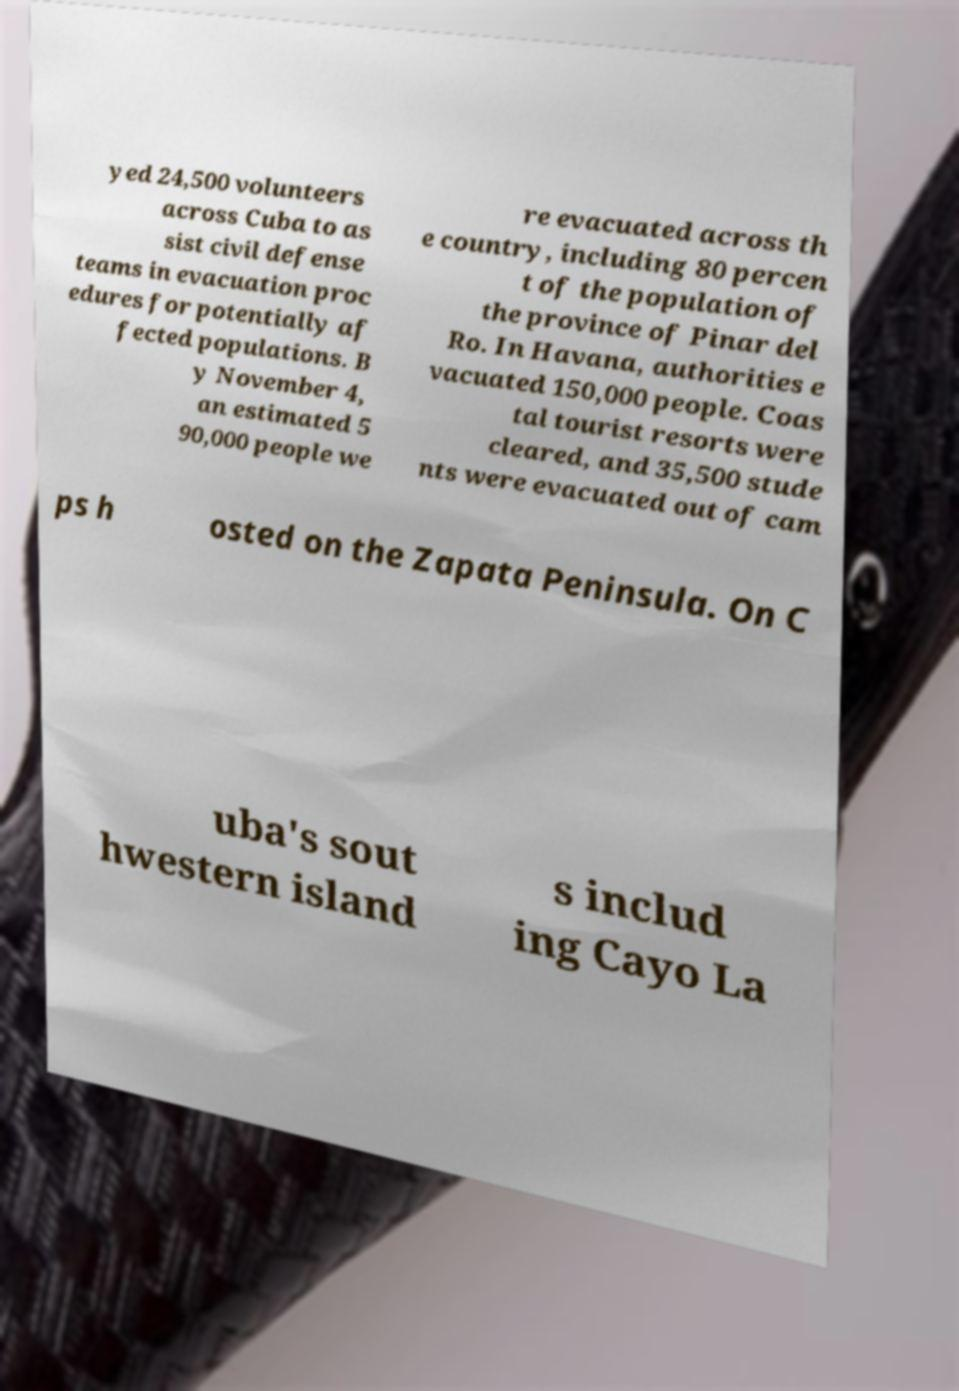Can you read and provide the text displayed in the image?This photo seems to have some interesting text. Can you extract and type it out for me? yed 24,500 volunteers across Cuba to as sist civil defense teams in evacuation proc edures for potentially af fected populations. B y November 4, an estimated 5 90,000 people we re evacuated across th e country, including 80 percen t of the population of the province of Pinar del Ro. In Havana, authorities e vacuated 150,000 people. Coas tal tourist resorts were cleared, and 35,500 stude nts were evacuated out of cam ps h osted on the Zapata Peninsula. On C uba's sout hwestern island s includ ing Cayo La 